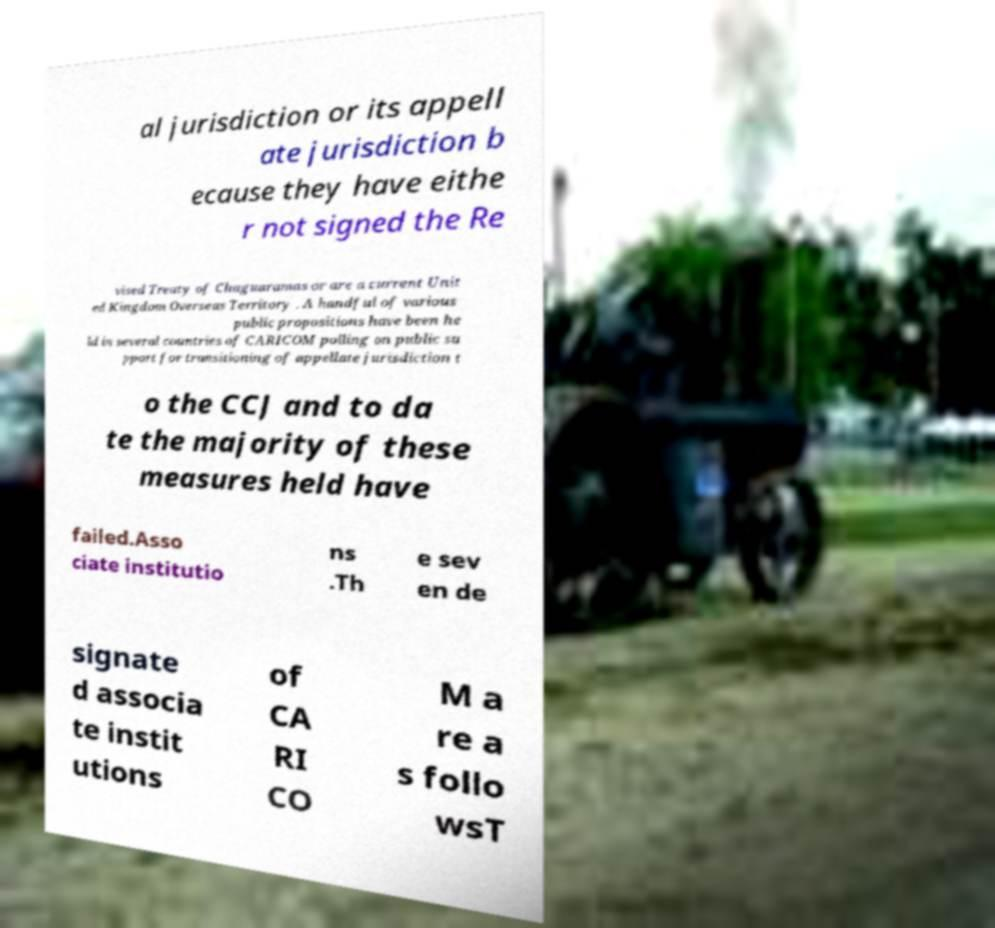Could you assist in decoding the text presented in this image and type it out clearly? al jurisdiction or its appell ate jurisdiction b ecause they have eithe r not signed the Re vised Treaty of Chaguaramas or are a current Unit ed Kingdom Overseas Territory . A handful of various public propositions have been he ld in several countries of CARICOM polling on public su pport for transitioning of appellate jurisdiction t o the CCJ and to da te the majority of these measures held have failed.Asso ciate institutio ns .Th e sev en de signate d associa te instit utions of CA RI CO M a re a s follo wsT 